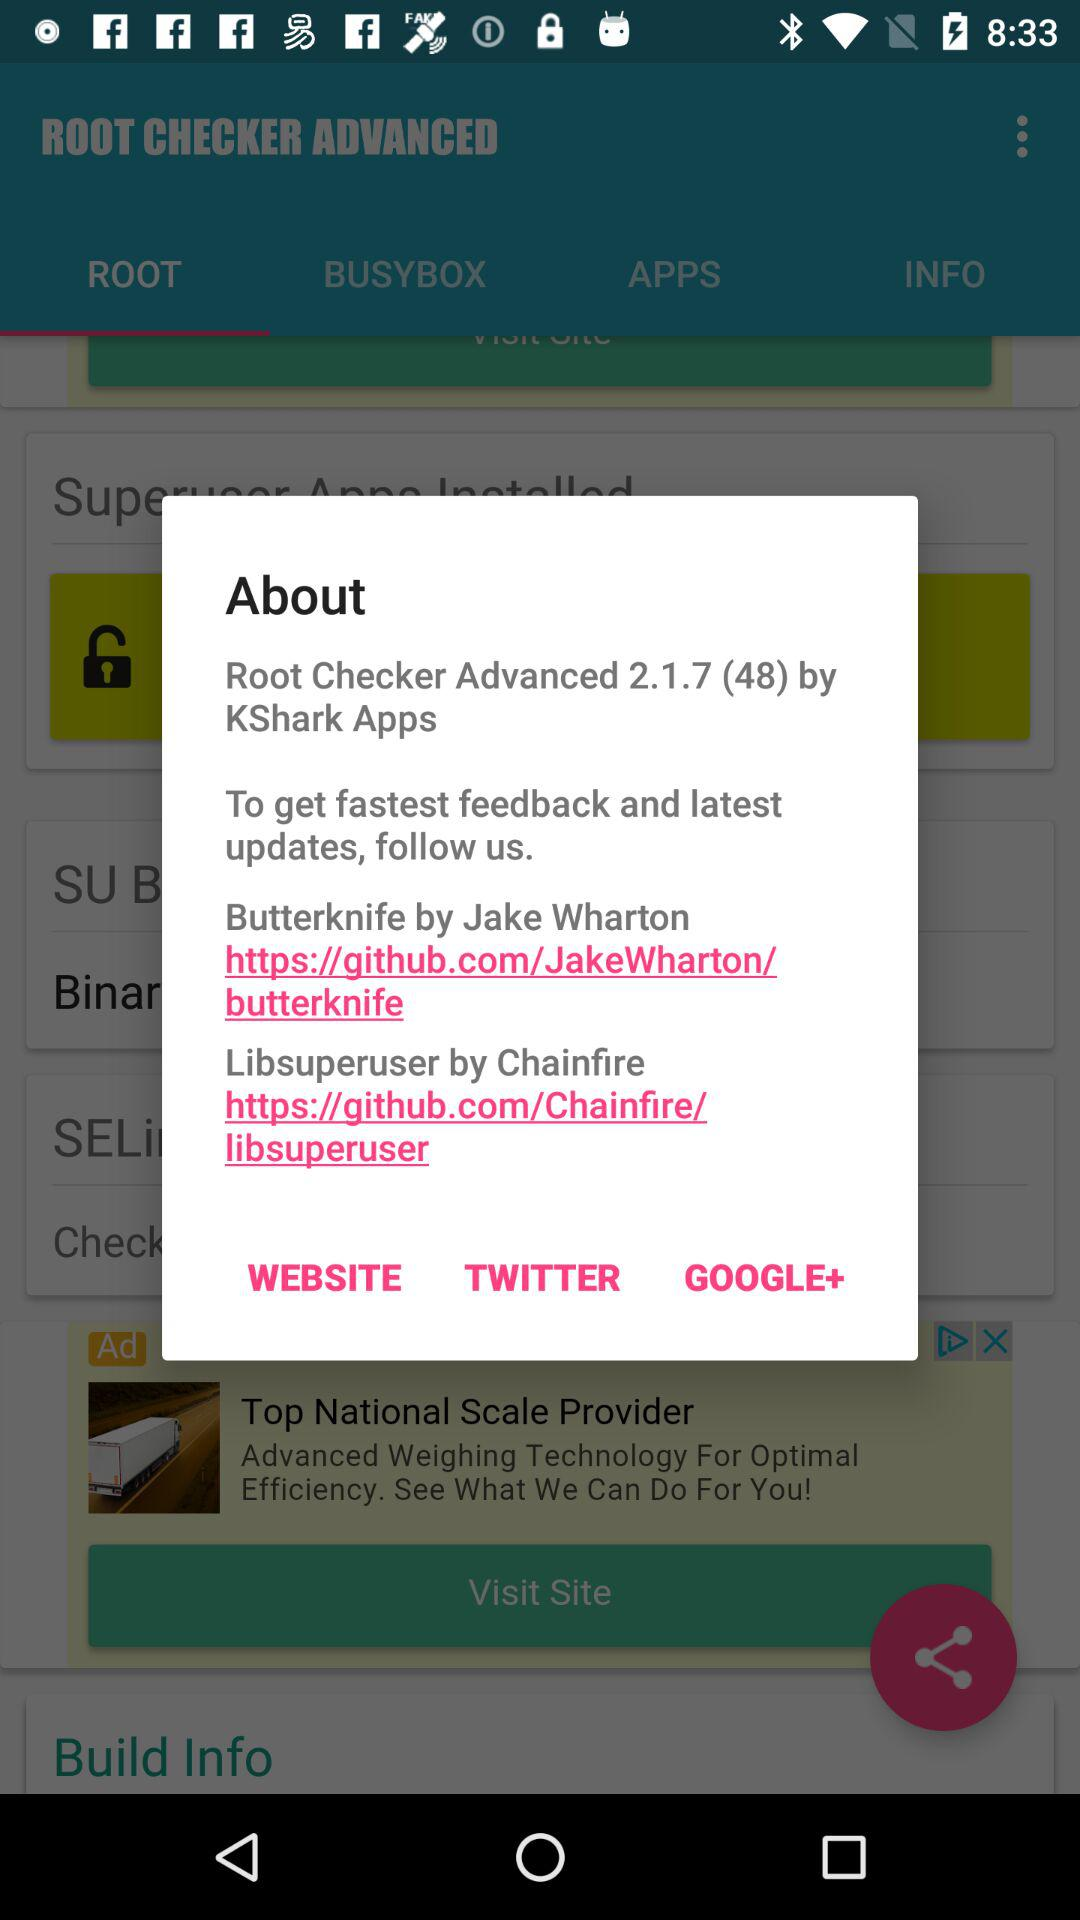What is the URL for "Butterknife" by Jake Wharton? The URL for "Butterknife" by Jake Wharton is https://github.com/JakeWharton/butterknife. 